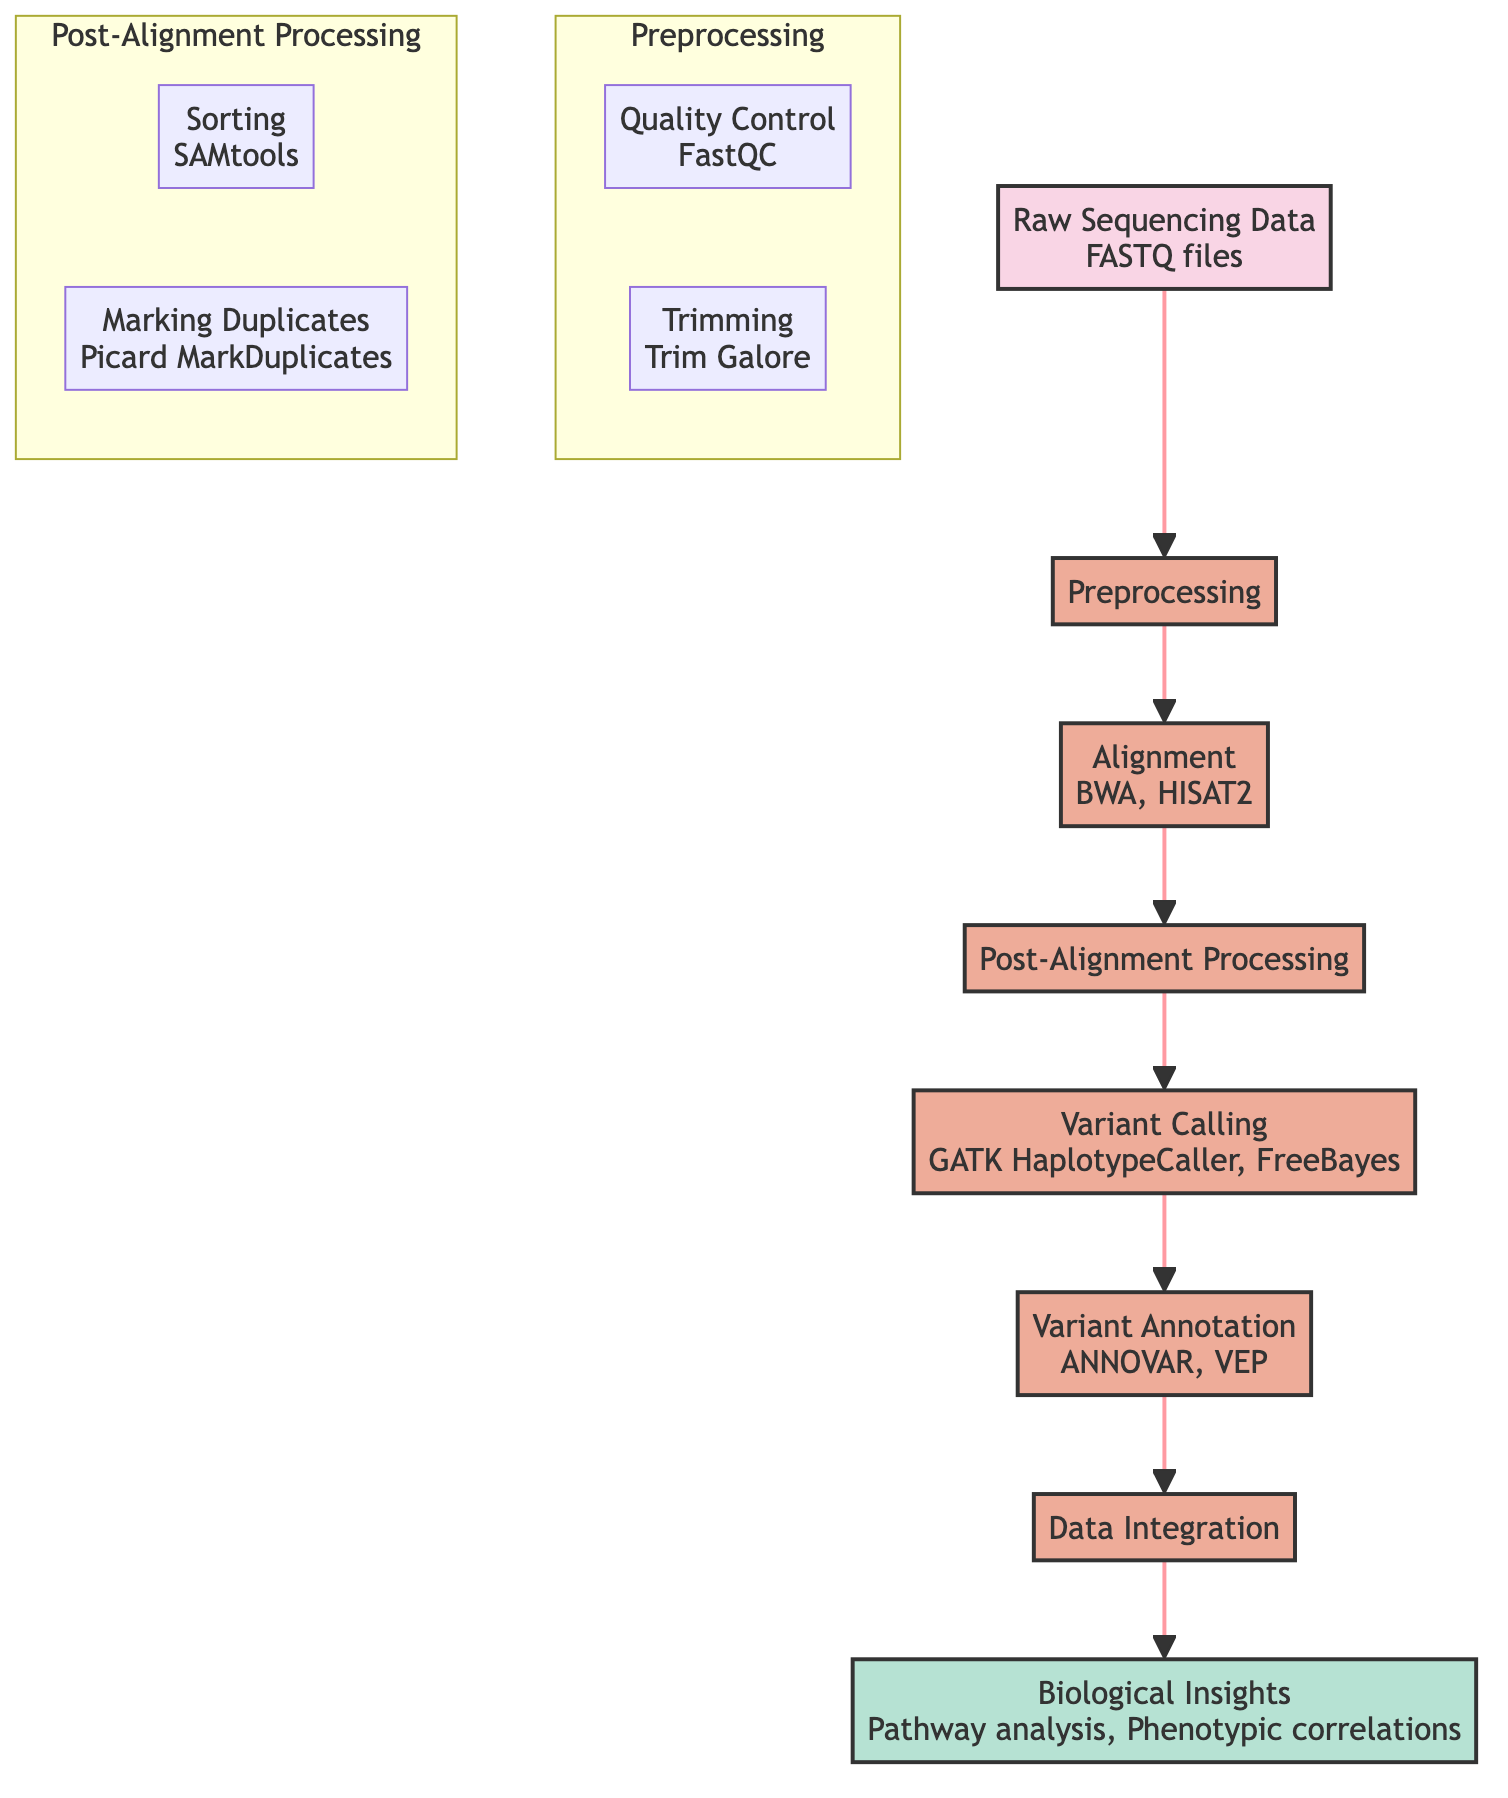What is the initial input of the diagram? The diagram starts with "Raw Sequencing Data," indicating that it is the initial input obtained from sequencing machines.
Answer: Raw Sequencing Data How many processes are depicted in the diagram? By counting the processes in the diagram, we find that there are 6 distinct processes listed: Preprocessing, Alignment, Post-Alignment Processing, Variant Calling, Variant Annotation, and Data Integration.
Answer: 6 What is the last step before obtaining Biological Insights? The step immediately preceding Biological Insights is Data Integration, where the annotated variants are combined with other biological datasets before generating insights.
Answer: Data Integration Which tools are mentioned for Quality Control in the Preprocessing step? The subprocess under Preprocessing that specifies the tool used for Quality Control is FastQC. It is listed alongside the Trimming subprocess.
Answer: FastQC What is the output of the entire pipeline? The final output of the pipeline after processing is "Biological Insights," which encompasses high-level interpretations derived from the data.
Answer: Biological Insights What subprocess follows the Alignment process? The immediate subprocess that follows Alignment in the diagram is Post-Alignment Processing. It involves additional processes applied to the aligned data.
Answer: Post-Alignment Processing What subprocess is involved in marking duplicates? The subprocess that deals with marking duplicates in the Post-Alignment Processing is Picard MarkDuplicates, which is specified in the diagram under that process.
Answer: Picard MarkDuplicates Which process involves GATK HaplotypeCaller? GATK HaplotypeCaller is part of the Variant Calling process, which aims to identify genetic variants from aligned sequences.
Answer: Variant Calling 